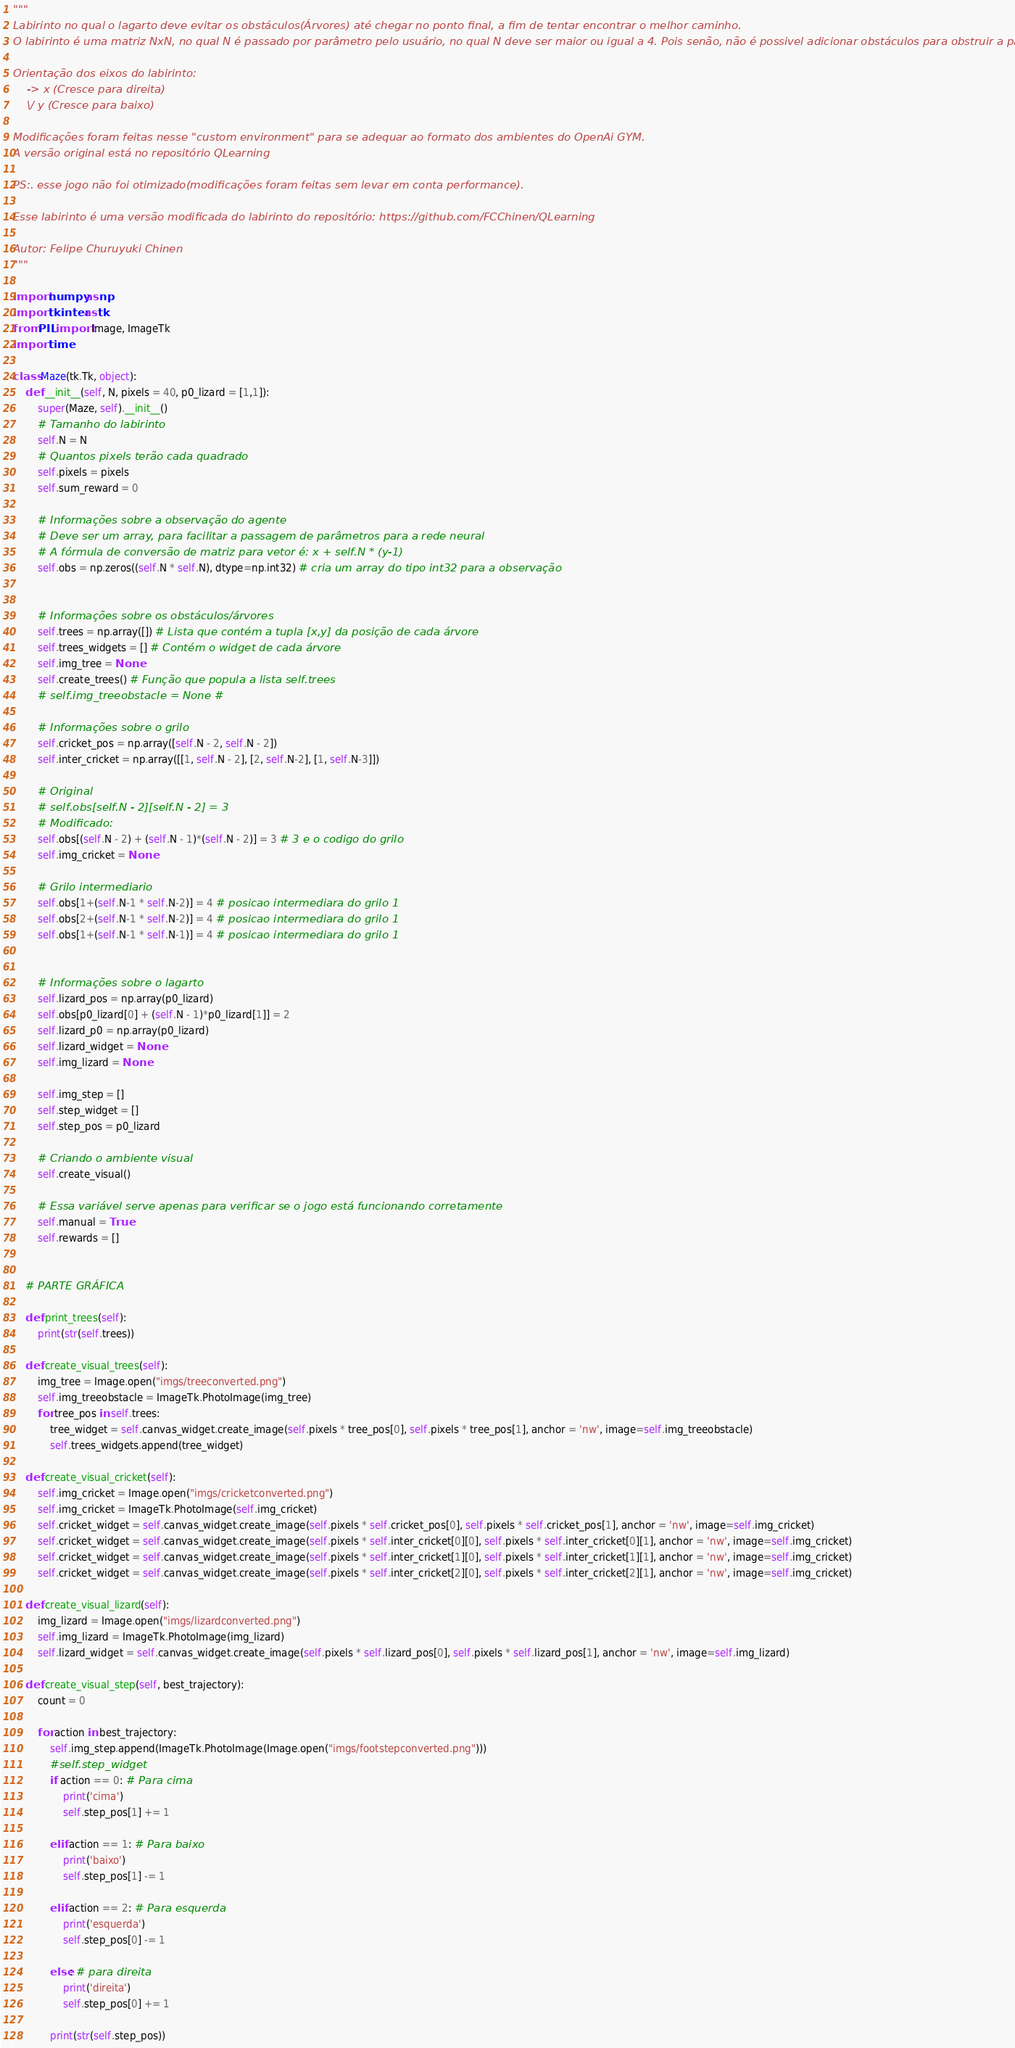Convert code to text. <code><loc_0><loc_0><loc_500><loc_500><_Python_>"""
Labirinto no qual o lagarto deve evitar os obstáculos(Árvores) até chegar no ponto final, a fim de tentar encontrar o melhor caminho.
O labirinto é uma matriz NxN, no qual N é passado por parâmetro pelo usuário, no qual N deve ser maior ou igual a 4. Pois senão, não é possivel adicionar obstáculos para obstruir a passagem do agente.

Orientação dos eixos do labirinto:
    -> x (Cresce para direita)
    \/ y (Cresce para baixo)

Modificações foram feitas nesse "custom environment" para se adequar ao formato dos ambientes do OpenAi GYM.
A versão original está no repositório QLearning

PS:. esse jogo não foi otimizado(modificações foram feitas sem levar em conta performance).

Esse labirinto é uma versão modificada do labirinto do repositório: https://github.com/FCChinen/QLearning

Autor: Felipe Churuyuki Chinen
"""

import numpy as np
import tkinter as tk
from PIL import Image, ImageTk
import time

class Maze(tk.Tk, object):
    def __init__(self, N, pixels = 40, p0_lizard = [1,1]):
        super(Maze, self).__init__()
        # Tamanho do labirinto
        self.N = N
        # Quantos pixels terão cada quadrado
        self.pixels = pixels
        self.sum_reward = 0

        # Informações sobre a observação do agente
        # Deve ser um array, para facilitar a passagem de parâmetros para a rede neural
        # A fórmula de conversão de matriz para vetor é: x + self.N * (y-1)
        self.obs = np.zeros((self.N * self.N), dtype=np.int32) # cria um array do tipo int32 para a observação
        

        # Informações sobre os obstáculos/árvores
        self.trees = np.array([]) # Lista que contém a tupla [x,y] da posição de cada árvore
        self.trees_widgets = [] # Contém o widget de cada árvore
        self.img_tree = None
        self.create_trees() # Função que popula a lista self.trees
        # self.img_treeobstacle = None # 

        # Informações sobre o grilo
        self.cricket_pos = np.array([self.N - 2, self.N - 2])
        self.inter_cricket = np.array([[1, self.N - 2], [2, self.N-2], [1, self.N-3]])

        # Original
        # self.obs[self.N - 2][self.N - 2] = 3
        # Modificado:
        self.obs[(self.N - 2) + (self.N - 1)*(self.N - 2)] = 3 # 3 e o codigo do grilo
        self.img_cricket = None
        
        # Grilo intermediario
        self.obs[1+(self.N-1 * self.N-2)] = 4 # posicao intermediara do grilo 1
        self.obs[2+(self.N-1 * self.N-2)] = 4 # posicao intermediara do grilo 1
        self.obs[1+(self.N-1 * self.N-1)] = 4 # posicao intermediara do grilo 1


        # Informações sobre o lagarto
        self.lizard_pos = np.array(p0_lizard)
        self.obs[p0_lizard[0] + (self.N - 1)*p0_lizard[1]] = 2
        self.lizard_p0 = np.array(p0_lizard)
        self.lizard_widget = None
        self.img_lizard = None

        self.img_step = []
        self.step_widget = []
        self.step_pos = p0_lizard

        # Criando o ambiente visual
        self.create_visual()

        # Essa variável serve apenas para verificar se o jogo está funcionando corretamente
        self.manual = True
        self.rewards = []

        
    # PARTE GRÁFICA

    def print_trees(self):
        print(str(self.trees))

    def create_visual_trees(self):
        img_tree = Image.open("imgs/treeconverted.png")
        self.img_treeobstacle = ImageTk.PhotoImage(img_tree)
        for tree_pos in self.trees:
            tree_widget = self.canvas_widget.create_image(self.pixels * tree_pos[0], self.pixels * tree_pos[1], anchor = 'nw', image=self.img_treeobstacle)
            self.trees_widgets.append(tree_widget)

    def create_visual_cricket(self):
        self.img_cricket = Image.open("imgs/cricketconverted.png")
        self.img_cricket = ImageTk.PhotoImage(self.img_cricket)
        self.cricket_widget = self.canvas_widget.create_image(self.pixels * self.cricket_pos[0], self.pixels * self.cricket_pos[1], anchor = 'nw', image=self.img_cricket)
        self.cricket_widget = self.canvas_widget.create_image(self.pixels * self.inter_cricket[0][0], self.pixels * self.inter_cricket[0][1], anchor = 'nw', image=self.img_cricket)
        self.cricket_widget = self.canvas_widget.create_image(self.pixels * self.inter_cricket[1][0], self.pixels * self.inter_cricket[1][1], anchor = 'nw', image=self.img_cricket)
        self.cricket_widget = self.canvas_widget.create_image(self.pixels * self.inter_cricket[2][0], self.pixels * self.inter_cricket[2][1], anchor = 'nw', image=self.img_cricket)
        
    def create_visual_lizard(self):
        img_lizard = Image.open("imgs/lizardconverted.png")
        self.img_lizard = ImageTk.PhotoImage(img_lizard)
        self.lizard_widget = self.canvas_widget.create_image(self.pixels * self.lizard_pos[0], self.pixels * self.lizard_pos[1], anchor = 'nw', image=self.img_lizard)

    def create_visual_step(self, best_trajectory):
        count = 0
        
        for action in best_trajectory:
            self.img_step.append(ImageTk.PhotoImage(Image.open("imgs/footstepconverted.png")))
            #self.step_widget
            if action == 0: # Para cima
                print('cima')
                self.step_pos[1] += 1

            elif action == 1: # Para baixo
                print('baixo')
                self.step_pos[1] -= 1

            elif action == 2: # Para esquerda
                print('esquerda')
                self.step_pos[0] -= 1

            else: # para direita
                print('direita')
                self.step_pos[0] += 1

            print(str(self.step_pos))</code> 